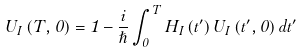Convert formula to latex. <formula><loc_0><loc_0><loc_500><loc_500>U _ { I } \left ( T , 0 \right ) = 1 - \frac { i } { \hslash } \int _ { 0 } ^ { T } H _ { I } \left ( t ^ { \prime } \right ) U _ { I } \left ( t ^ { \prime } , 0 \right ) d t ^ { \prime }</formula> 